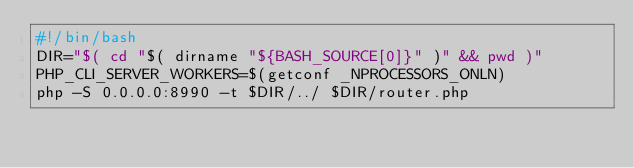<code> <loc_0><loc_0><loc_500><loc_500><_Bash_>#!/bin/bash
DIR="$( cd "$( dirname "${BASH_SOURCE[0]}" )" && pwd )"
PHP_CLI_SERVER_WORKERS=$(getconf _NPROCESSORS_ONLN)
php -S 0.0.0.0:8990 -t $DIR/../ $DIR/router.php
</code> 